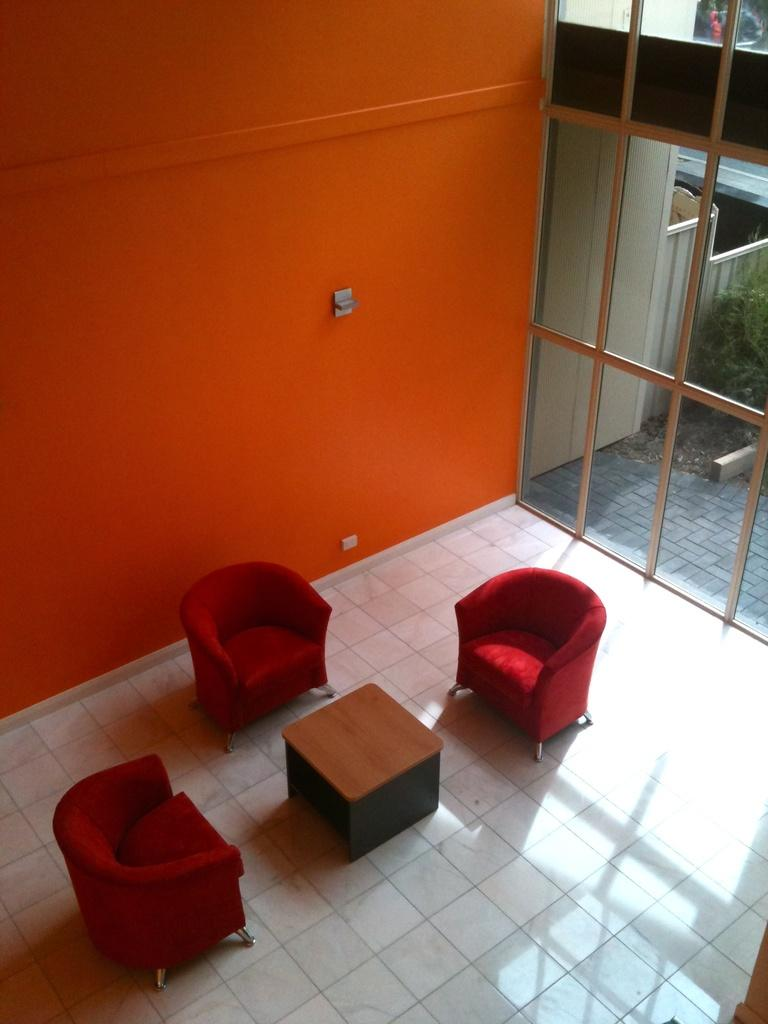What type of space is depicted in the image? There is a room in the image. How many chairs are in the room? There are three chairs in the room. What is located in front of the chairs? There is a table in front of the chairs. What can be seen through the window in the room? Plants are visible through the window. What material is the window made of? The window is made of glass. What year is depicted in the image? The image does not depict a specific year; it is a still image of a room with chairs, a table, and a window. Are there any boats visible in the image? No, there are no boats present in the image. 